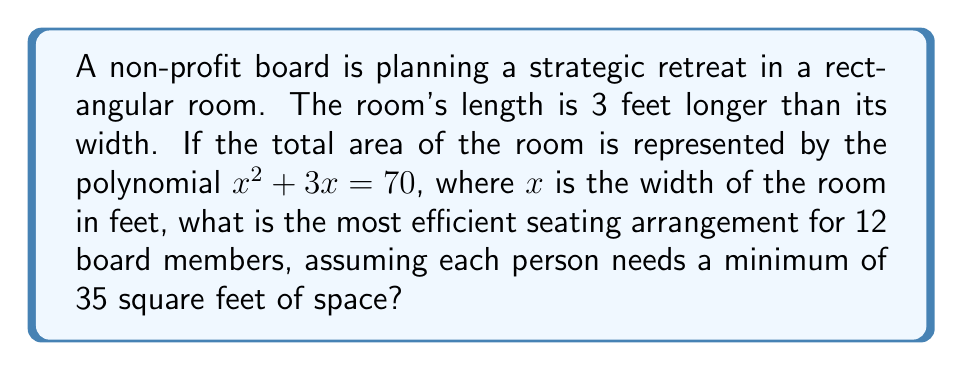Show me your answer to this math problem. 1) First, we need to solve the polynomial equation to find the dimensions of the room:
   $x^2 + 3x = 70$
   $x^2 + 3x - 70 = 0$

2) Using the quadratic formula: $x = \frac{-b \pm \sqrt{b^2 - 4ac}}{2a}$
   $x = \frac{-3 \pm \sqrt{3^2 - 4(1)(-70)}}{2(1)}$
   $x = \frac{-3 \pm \sqrt{9 + 280}}{2} = \frac{-3 \pm \sqrt{289}}{2} = \frac{-3 \pm 17}{2}$

3) Since width can't be negative, we take the positive solution:
   $x = \frac{-3 + 17}{2} = 7$

4) So, the width of the room is 7 feet, and the length is 7 + 3 = 10 feet.

5) The total area of the room is:
   $A = 7 \times 10 = 70$ square feet

6) With 12 board members and a minimum of 35 square feet per person, we need:
   $12 \times 35 = 420$ square feet

7) Since the room is only 70 square feet, it's not possible to accommodate all 12 members with the required 35 square feet each.

8) The most efficient arrangement would be to maximize the number of people that can fit:
   $70 \div 35 \approx 2$ people

9) Therefore, the most efficient seating arrangement would be for 2 people, with each person having 35 square feet of space.
Answer: 2 people 